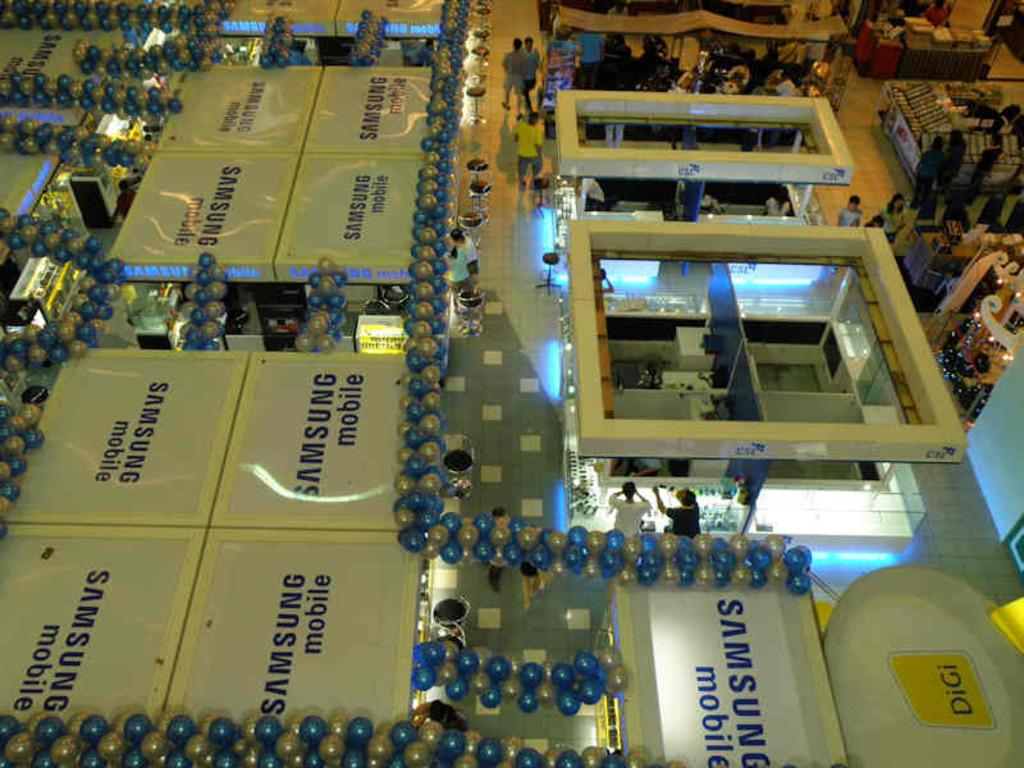What type of view is provided in the image? The image is an aerial view. What can be seen on the ground in the image? There are boards, balloons, chairs, people, stores, the floor, and other objects visible in the image. What is present above the ground in the image? The roof and lights are present in the image. What type of iron can be seen being used by the people in the image? There is no iron present in the image; it is an aerial view of a location with various objects and structures. Can you describe the breath of the people in the image? There is no way to determine the breath of the people in the image, as it is a still photograph. 